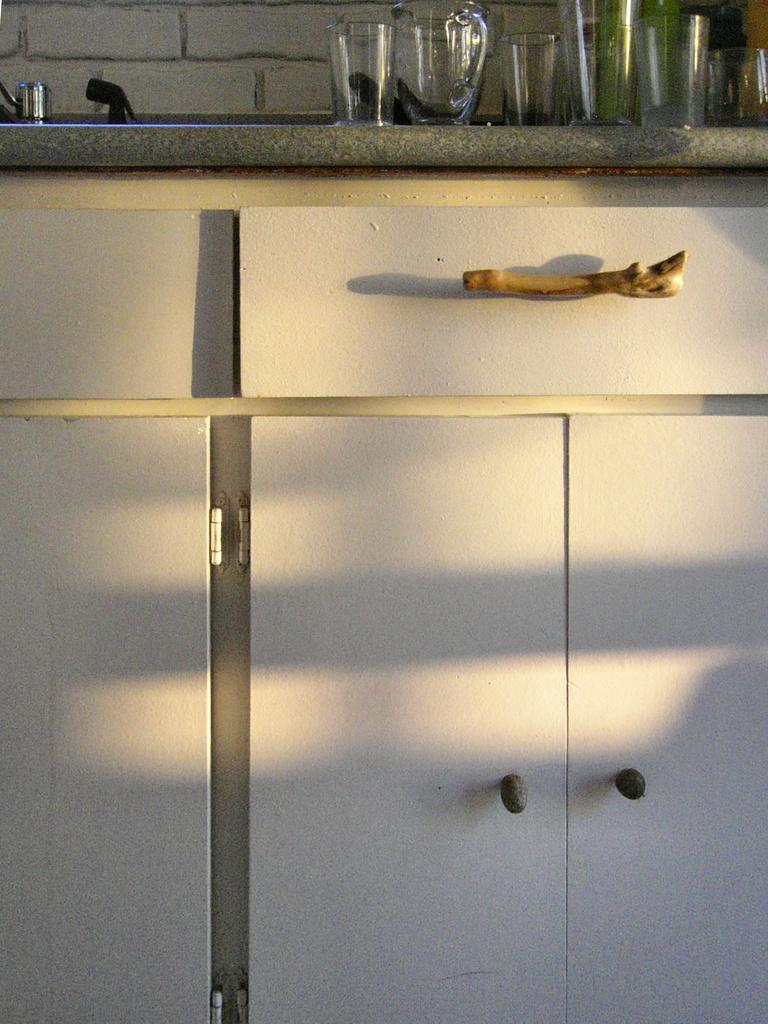What is located in the center of the image? There is a wall, a table, a brown color object, and cupboards in the center of the image. What is on the table in the image? There are glasses, a jar, and other objects on the table. What color is the object in the center of the image? The object in the center of the image is brown. What type of furniture is present in the image? There is a table and cupboards in the image. Can you see any waves or sea creatures in the image? No, there is no reference to a sea or any sea creatures in the image. 